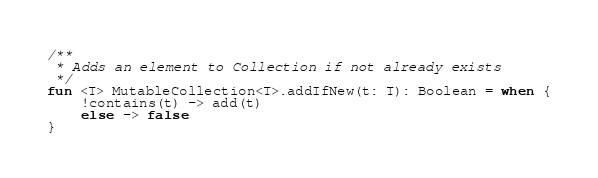Convert code to text. <code><loc_0><loc_0><loc_500><loc_500><_Kotlin_>
/**
 * Adds an element to Collection if not already exists
 */
fun <T> MutableCollection<T>.addIfNew(t: T): Boolean = when {
    !contains(t) -> add(t)
    else -> false
}
</code> 